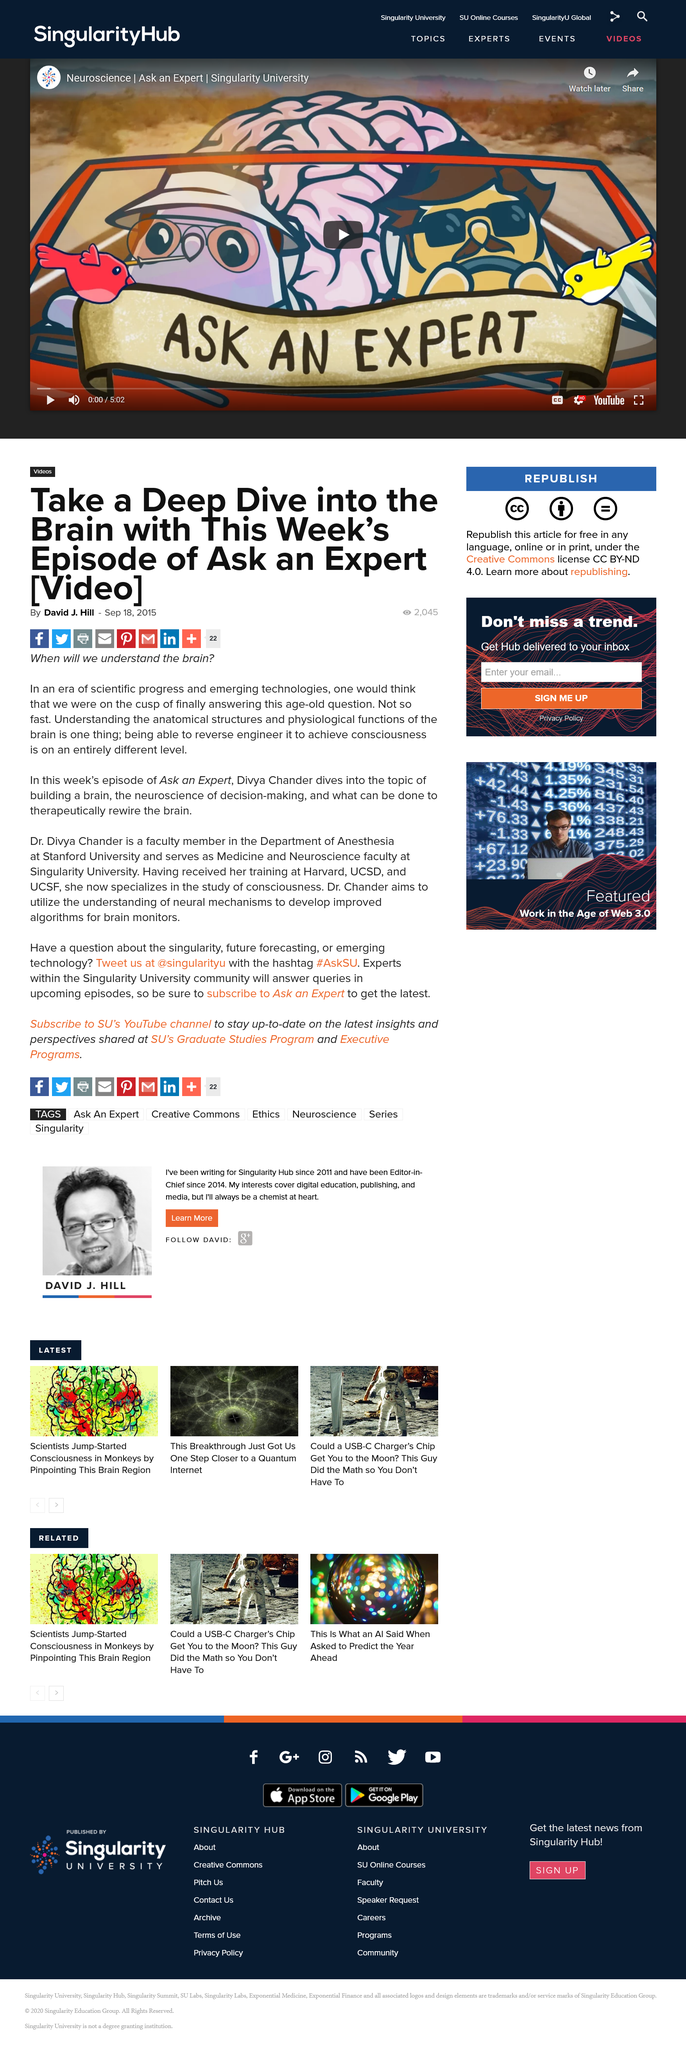Highlight a few significant elements in this photo. Dr. Divya Chander received formal training at Harvard, UCSD, and UCSF. I, David J. Hill, am the author of this article and it is permissible to share it on Facebook. Dr. Divya Chander is a faculty member at Stanford University, as stated in the declaration. 